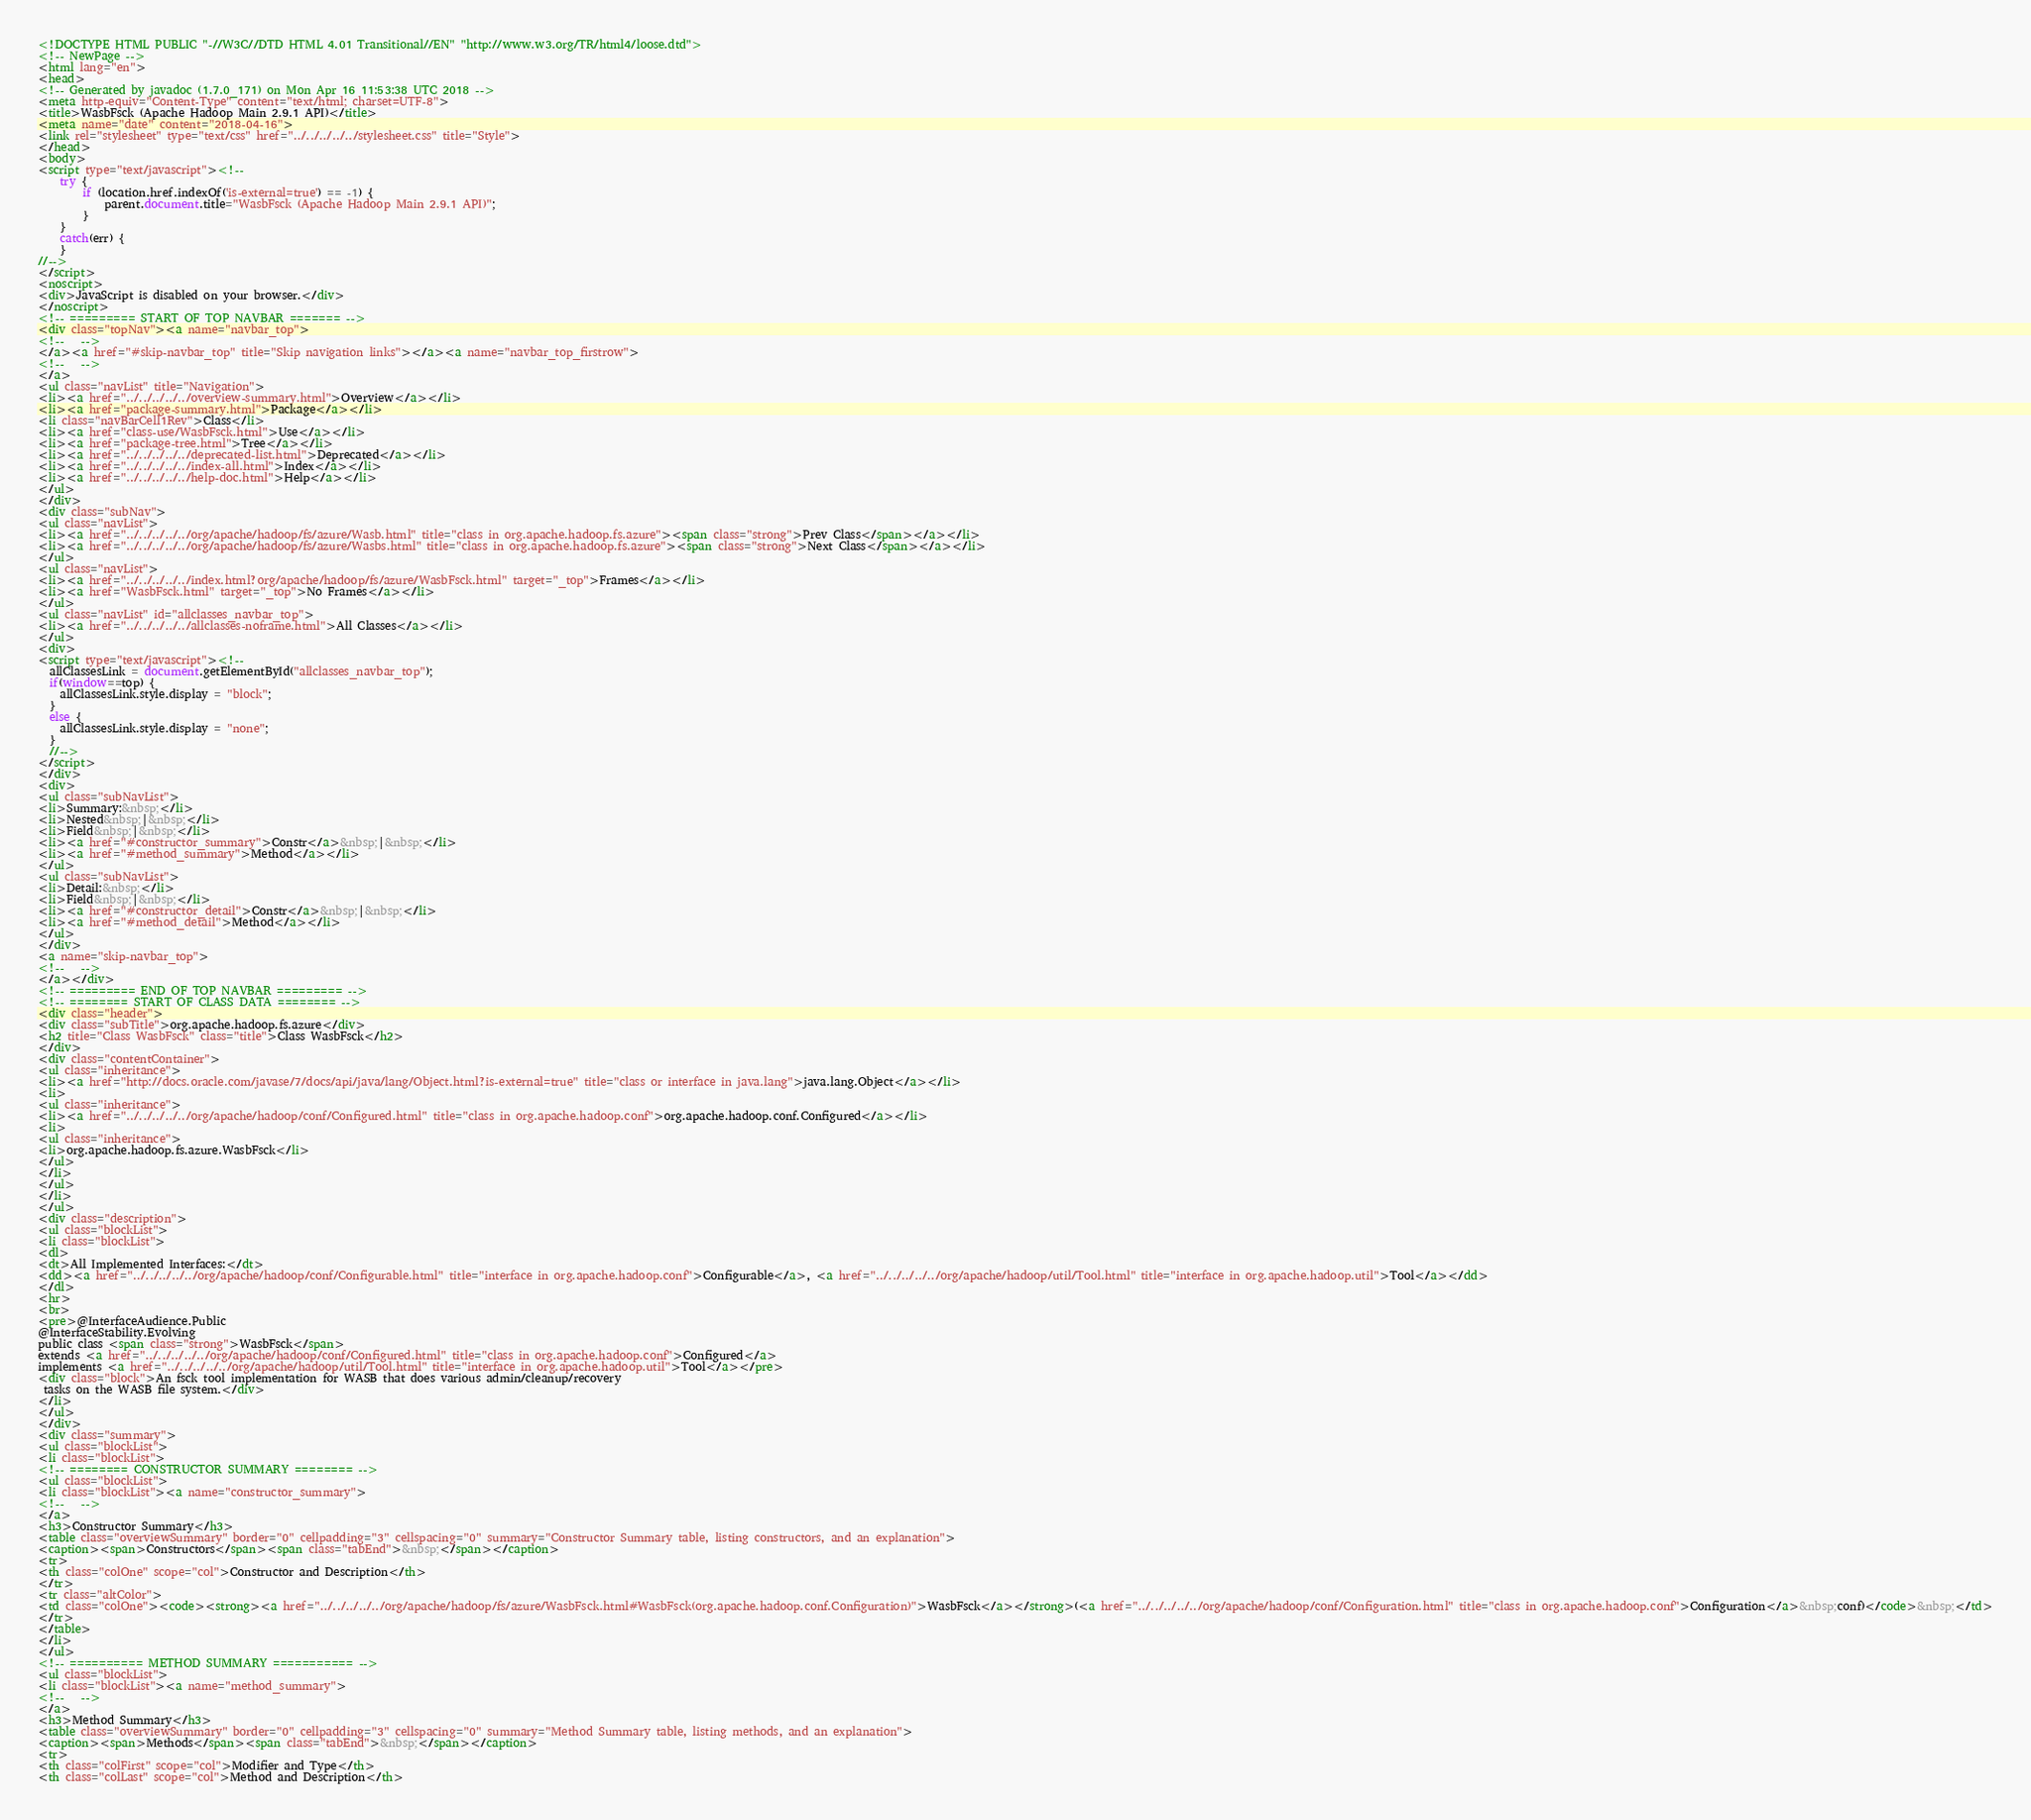<code> <loc_0><loc_0><loc_500><loc_500><_HTML_><!DOCTYPE HTML PUBLIC "-//W3C//DTD HTML 4.01 Transitional//EN" "http://www.w3.org/TR/html4/loose.dtd">
<!-- NewPage -->
<html lang="en">
<head>
<!-- Generated by javadoc (1.7.0_171) on Mon Apr 16 11:53:38 UTC 2018 -->
<meta http-equiv="Content-Type" content="text/html; charset=UTF-8">
<title>WasbFsck (Apache Hadoop Main 2.9.1 API)</title>
<meta name="date" content="2018-04-16">
<link rel="stylesheet" type="text/css" href="../../../../../stylesheet.css" title="Style">
</head>
<body>
<script type="text/javascript"><!--
    try {
        if (location.href.indexOf('is-external=true') == -1) {
            parent.document.title="WasbFsck (Apache Hadoop Main 2.9.1 API)";
        }
    }
    catch(err) {
    }
//-->
</script>
<noscript>
<div>JavaScript is disabled on your browser.</div>
</noscript>
<!-- ========= START OF TOP NAVBAR ======= -->
<div class="topNav"><a name="navbar_top">
<!--   -->
</a><a href="#skip-navbar_top" title="Skip navigation links"></a><a name="navbar_top_firstrow">
<!--   -->
</a>
<ul class="navList" title="Navigation">
<li><a href="../../../../../overview-summary.html">Overview</a></li>
<li><a href="package-summary.html">Package</a></li>
<li class="navBarCell1Rev">Class</li>
<li><a href="class-use/WasbFsck.html">Use</a></li>
<li><a href="package-tree.html">Tree</a></li>
<li><a href="../../../../../deprecated-list.html">Deprecated</a></li>
<li><a href="../../../../../index-all.html">Index</a></li>
<li><a href="../../../../../help-doc.html">Help</a></li>
</ul>
</div>
<div class="subNav">
<ul class="navList">
<li><a href="../../../../../org/apache/hadoop/fs/azure/Wasb.html" title="class in org.apache.hadoop.fs.azure"><span class="strong">Prev Class</span></a></li>
<li><a href="../../../../../org/apache/hadoop/fs/azure/Wasbs.html" title="class in org.apache.hadoop.fs.azure"><span class="strong">Next Class</span></a></li>
</ul>
<ul class="navList">
<li><a href="../../../../../index.html?org/apache/hadoop/fs/azure/WasbFsck.html" target="_top">Frames</a></li>
<li><a href="WasbFsck.html" target="_top">No Frames</a></li>
</ul>
<ul class="navList" id="allclasses_navbar_top">
<li><a href="../../../../../allclasses-noframe.html">All Classes</a></li>
</ul>
<div>
<script type="text/javascript"><!--
  allClassesLink = document.getElementById("allclasses_navbar_top");
  if(window==top) {
    allClassesLink.style.display = "block";
  }
  else {
    allClassesLink.style.display = "none";
  }
  //-->
</script>
</div>
<div>
<ul class="subNavList">
<li>Summary:&nbsp;</li>
<li>Nested&nbsp;|&nbsp;</li>
<li>Field&nbsp;|&nbsp;</li>
<li><a href="#constructor_summary">Constr</a>&nbsp;|&nbsp;</li>
<li><a href="#method_summary">Method</a></li>
</ul>
<ul class="subNavList">
<li>Detail:&nbsp;</li>
<li>Field&nbsp;|&nbsp;</li>
<li><a href="#constructor_detail">Constr</a>&nbsp;|&nbsp;</li>
<li><a href="#method_detail">Method</a></li>
</ul>
</div>
<a name="skip-navbar_top">
<!--   -->
</a></div>
<!-- ========= END OF TOP NAVBAR ========= -->
<!-- ======== START OF CLASS DATA ======== -->
<div class="header">
<div class="subTitle">org.apache.hadoop.fs.azure</div>
<h2 title="Class WasbFsck" class="title">Class WasbFsck</h2>
</div>
<div class="contentContainer">
<ul class="inheritance">
<li><a href="http://docs.oracle.com/javase/7/docs/api/java/lang/Object.html?is-external=true" title="class or interface in java.lang">java.lang.Object</a></li>
<li>
<ul class="inheritance">
<li><a href="../../../../../org/apache/hadoop/conf/Configured.html" title="class in org.apache.hadoop.conf">org.apache.hadoop.conf.Configured</a></li>
<li>
<ul class="inheritance">
<li>org.apache.hadoop.fs.azure.WasbFsck</li>
</ul>
</li>
</ul>
</li>
</ul>
<div class="description">
<ul class="blockList">
<li class="blockList">
<dl>
<dt>All Implemented Interfaces:</dt>
<dd><a href="../../../../../org/apache/hadoop/conf/Configurable.html" title="interface in org.apache.hadoop.conf">Configurable</a>, <a href="../../../../../org/apache/hadoop/util/Tool.html" title="interface in org.apache.hadoop.util">Tool</a></dd>
</dl>
<hr>
<br>
<pre>@InterfaceAudience.Public
@InterfaceStability.Evolving
public class <span class="strong">WasbFsck</span>
extends <a href="../../../../../org/apache/hadoop/conf/Configured.html" title="class in org.apache.hadoop.conf">Configured</a>
implements <a href="../../../../../org/apache/hadoop/util/Tool.html" title="interface in org.apache.hadoop.util">Tool</a></pre>
<div class="block">An fsck tool implementation for WASB that does various admin/cleanup/recovery
 tasks on the WASB file system.</div>
</li>
</ul>
</div>
<div class="summary">
<ul class="blockList">
<li class="blockList">
<!-- ======== CONSTRUCTOR SUMMARY ======== -->
<ul class="blockList">
<li class="blockList"><a name="constructor_summary">
<!--   -->
</a>
<h3>Constructor Summary</h3>
<table class="overviewSummary" border="0" cellpadding="3" cellspacing="0" summary="Constructor Summary table, listing constructors, and an explanation">
<caption><span>Constructors</span><span class="tabEnd">&nbsp;</span></caption>
<tr>
<th class="colOne" scope="col">Constructor and Description</th>
</tr>
<tr class="altColor">
<td class="colOne"><code><strong><a href="../../../../../org/apache/hadoop/fs/azure/WasbFsck.html#WasbFsck(org.apache.hadoop.conf.Configuration)">WasbFsck</a></strong>(<a href="../../../../../org/apache/hadoop/conf/Configuration.html" title="class in org.apache.hadoop.conf">Configuration</a>&nbsp;conf)</code>&nbsp;</td>
</tr>
</table>
</li>
</ul>
<!-- ========== METHOD SUMMARY =========== -->
<ul class="blockList">
<li class="blockList"><a name="method_summary">
<!--   -->
</a>
<h3>Method Summary</h3>
<table class="overviewSummary" border="0" cellpadding="3" cellspacing="0" summary="Method Summary table, listing methods, and an explanation">
<caption><span>Methods</span><span class="tabEnd">&nbsp;</span></caption>
<tr>
<th class="colFirst" scope="col">Modifier and Type</th>
<th class="colLast" scope="col">Method and Description</th></code> 